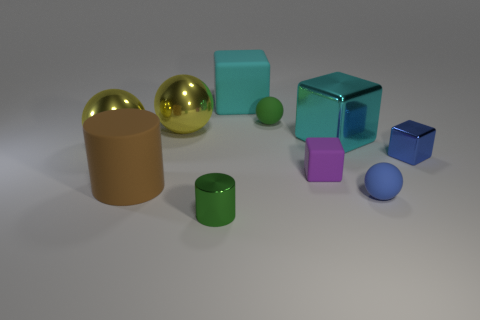Subtract all green matte spheres. How many spheres are left? 3 Subtract all blocks. How many objects are left? 6 Subtract all green spheres. How many spheres are left? 3 Subtract 2 blocks. How many blocks are left? 2 Subtract all purple cylinders. Subtract all red balls. How many cylinders are left? 2 Subtract all gray cylinders. How many green spheres are left? 1 Subtract all small blocks. Subtract all tiny matte blocks. How many objects are left? 7 Add 9 small blue metal cubes. How many small blue metal cubes are left? 10 Add 3 green spheres. How many green spheres exist? 4 Subtract 0 gray cylinders. How many objects are left? 10 